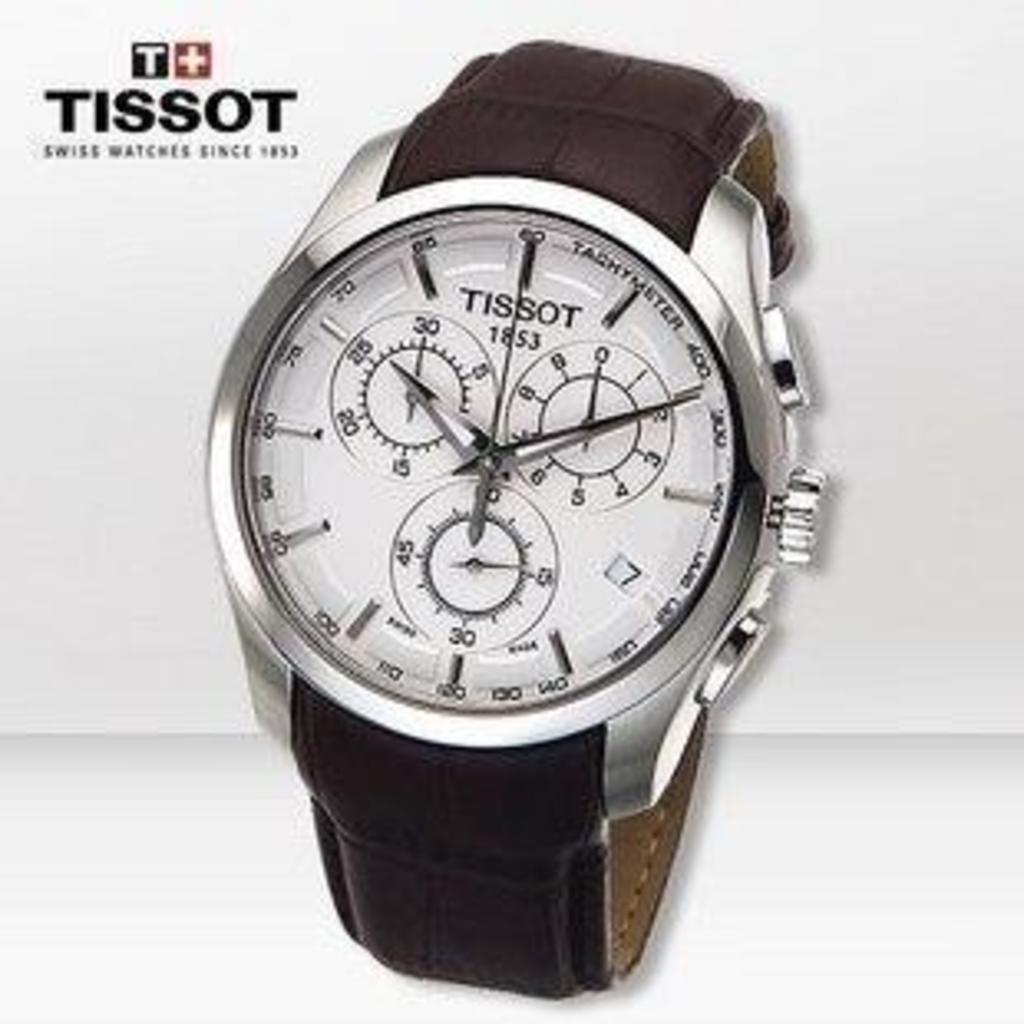<image>
Write a terse but informative summary of the picture. An advertisement with the image of a Tissot watch with a brown band. 